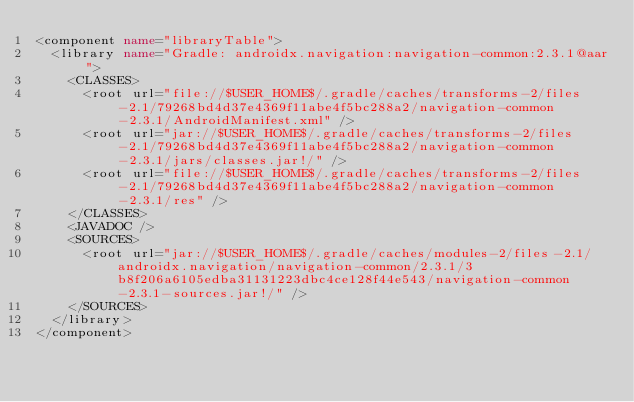<code> <loc_0><loc_0><loc_500><loc_500><_XML_><component name="libraryTable">
  <library name="Gradle: androidx.navigation:navigation-common:2.3.1@aar">
    <CLASSES>
      <root url="file://$USER_HOME$/.gradle/caches/transforms-2/files-2.1/79268bd4d37e4369f11abe4f5bc288a2/navigation-common-2.3.1/AndroidManifest.xml" />
      <root url="jar://$USER_HOME$/.gradle/caches/transforms-2/files-2.1/79268bd4d37e4369f11abe4f5bc288a2/navigation-common-2.3.1/jars/classes.jar!/" />
      <root url="file://$USER_HOME$/.gradle/caches/transforms-2/files-2.1/79268bd4d37e4369f11abe4f5bc288a2/navigation-common-2.3.1/res" />
    </CLASSES>
    <JAVADOC />
    <SOURCES>
      <root url="jar://$USER_HOME$/.gradle/caches/modules-2/files-2.1/androidx.navigation/navigation-common/2.3.1/3b8f206a6105edba31131223dbc4ce128f44e543/navigation-common-2.3.1-sources.jar!/" />
    </SOURCES>
  </library>
</component></code> 